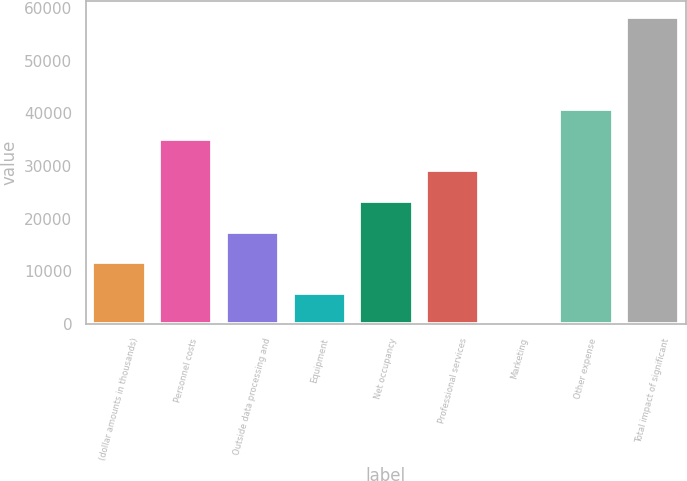Convert chart to OTSL. <chart><loc_0><loc_0><loc_500><loc_500><bar_chart><fcel>(dollar amounts in thousands)<fcel>Personnel costs<fcel>Outside data processing and<fcel>Equipment<fcel>Net occupancy<fcel>Professional services<fcel>Marketing<fcel>Other expense<fcel>Total impact of significant<nl><fcel>11695.8<fcel>35031.4<fcel>17529.7<fcel>5861.9<fcel>23363.6<fcel>29197.5<fcel>28<fcel>40865.3<fcel>58367<nl></chart> 